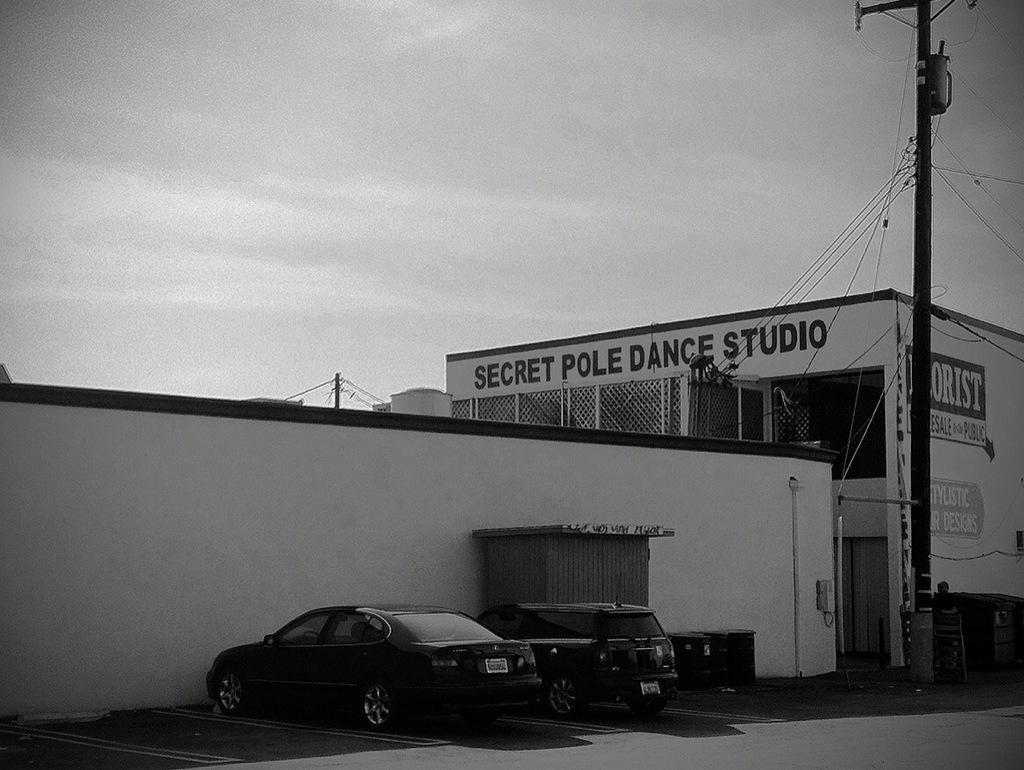In one or two sentences, can you explain what this image depicts? This is a black and white image. I can see two cars, which are parked. This is a building with the windows. I think this is a current pole with the current wires. This is the wall. I can see the barrels, which are beside the car. This is the sky. 